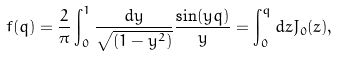<formula> <loc_0><loc_0><loc_500><loc_500>f ( q ) = \frac { 2 } { \pi } \int _ { 0 } ^ { 1 } \frac { d y } { \sqrt { ( 1 - y ^ { 2 } ) } } \frac { \sin ( y q ) } { y } = \int ^ { q } _ { 0 } d z J _ { 0 } ( z ) ,</formula> 